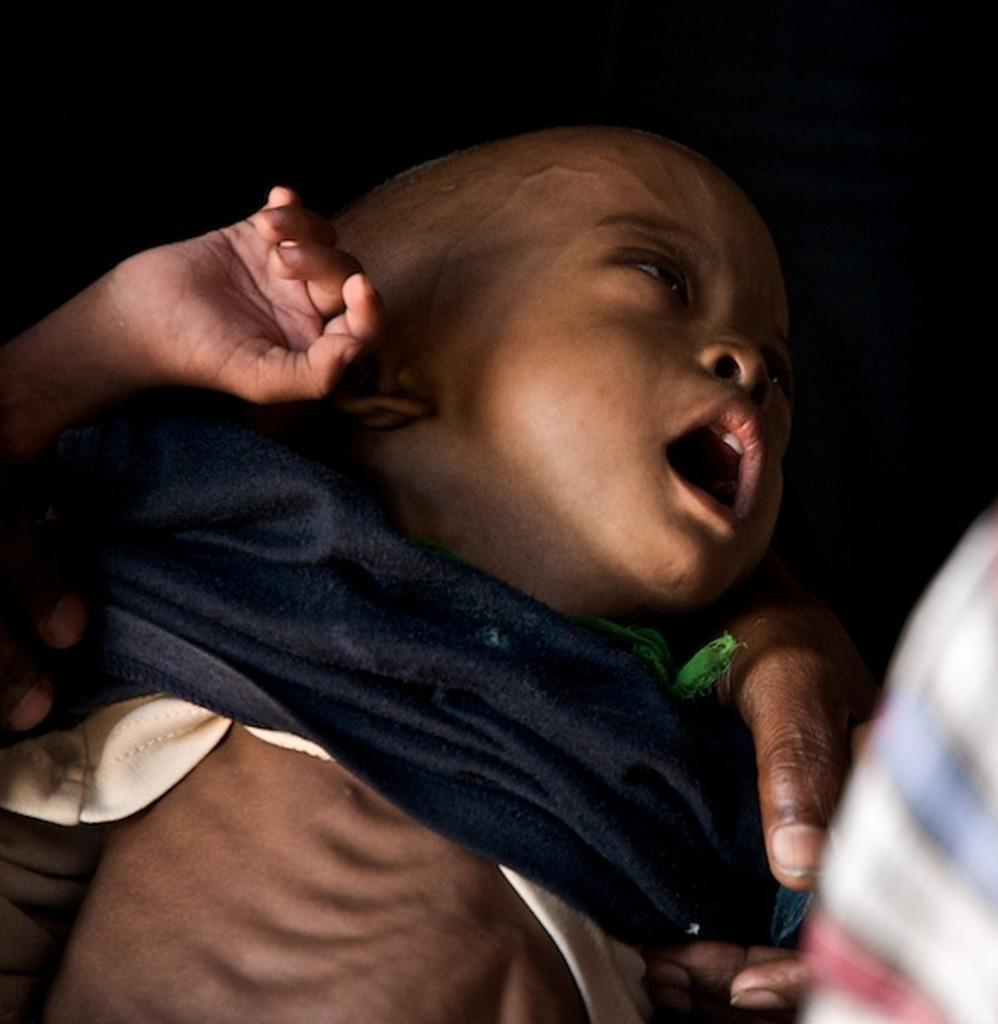Who is present in the image? There is a person in the image. What is the person doing in the image? The person is holding a baby. What type of rabbit can be seen hiding in the bushes in the image? There is no rabbit or bushes present in the image; it only features a person holding a baby. 